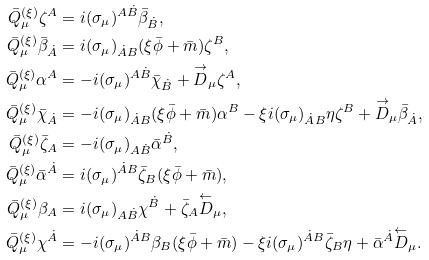Convert formula to latex. <formula><loc_0><loc_0><loc_500><loc_500>\bar { Q } _ { \mu } ^ { ( \xi ) } \zeta ^ { A } & = i ( \sigma _ { \mu } ) ^ { A \dot { B } } \bar { \beta } _ { \dot { B } } , \\ \bar { Q } _ { \mu } ^ { ( \xi ) } \bar { \beta } _ { \dot { A } } & = i ( \sigma _ { \mu } ) _ { \dot { A } B } ( \xi \bar { \phi } + \bar { m } ) \zeta ^ { B } , \\ \bar { Q } _ { \mu } ^ { ( \xi ) } \alpha ^ { A } & = - i ( \sigma _ { \mu } ) ^ { A \dot { B } } \bar { \chi } _ { \dot { B } } + \overset { \rightarrow } { D } _ { \mu } \zeta ^ { A } , \\ \bar { Q } _ { \mu } ^ { ( \xi ) } \bar { \chi } _ { \dot { A } } & = - i ( \sigma _ { \mu } ) _ { \dot { A } B } ( \xi \bar { \phi } + \bar { m } ) \alpha ^ { B } - \xi i ( \sigma _ { \mu } ) _ { \dot { A } B } \eta \zeta ^ { B } + \overset { \rightarrow } { D } _ { \mu } \bar { \beta } _ { \dot { A } } , \\ \bar { Q } _ { \mu } ^ { ( \xi ) } \bar { \zeta } _ { A } & = - i ( \sigma _ { \mu } ) _ { A \dot { B } } \bar { \alpha } ^ { \dot { B } } , \\ \bar { Q } _ { \mu } ^ { ( \xi ) } \bar { \alpha } ^ { \dot { A } } & = i ( \sigma _ { \mu } ) ^ { \dot { A } B } \bar { \zeta } _ { B } ( \xi \bar { \phi } + \bar { m } ) , \\ \bar { Q } _ { \mu } ^ { ( \xi ) } \beta _ { A } & = i ( \sigma _ { \mu } ) _ { A \dot { B } } \chi ^ { \dot { B } } + \bar { \zeta } _ { A } \overset { \leftarrow } { D } _ { \mu } , \\ \bar { Q } _ { \mu } ^ { ( \xi ) } \chi ^ { \dot { A } } & = - i ( \sigma _ { \mu } ) ^ { \dot { A } B } \beta _ { B } ( \xi \bar { \phi } + \bar { m } ) - \xi i ( \sigma _ { \mu } ) ^ { \dot { A } B } \bar { \zeta } _ { B } \eta + \bar { \alpha } ^ { \dot { A } } \overset { \leftarrow } { D } _ { \mu } .</formula> 